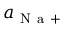<formula> <loc_0><loc_0><loc_500><loc_500>a _ { N a + }</formula> 